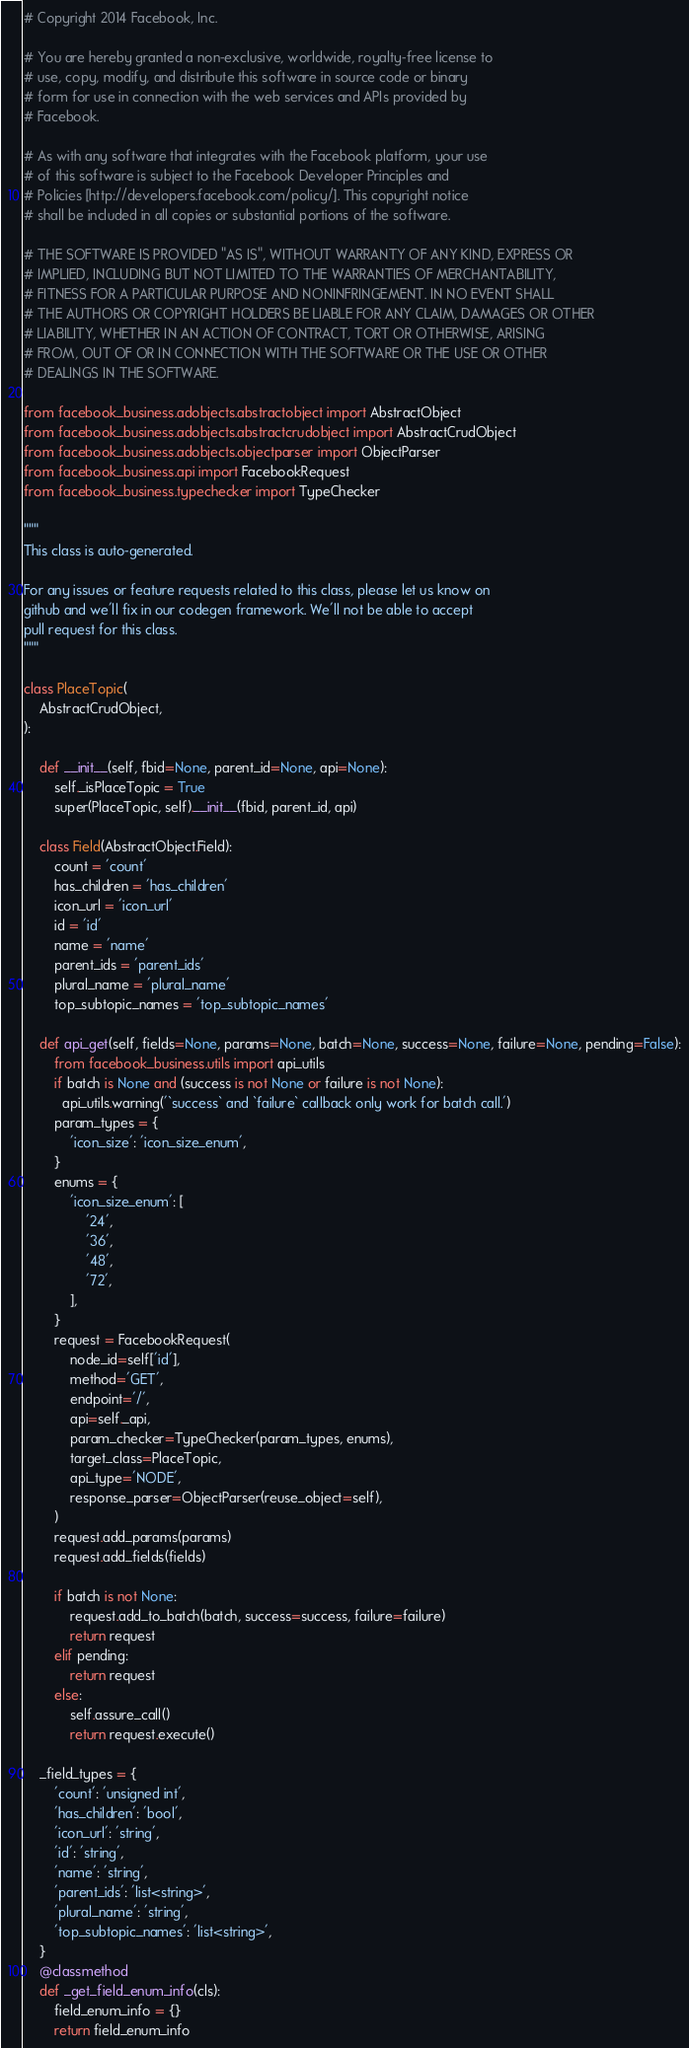<code> <loc_0><loc_0><loc_500><loc_500><_Python_># Copyright 2014 Facebook, Inc.

# You are hereby granted a non-exclusive, worldwide, royalty-free license to
# use, copy, modify, and distribute this software in source code or binary
# form for use in connection with the web services and APIs provided by
# Facebook.

# As with any software that integrates with the Facebook platform, your use
# of this software is subject to the Facebook Developer Principles and
# Policies [http://developers.facebook.com/policy/]. This copyright notice
# shall be included in all copies or substantial portions of the software.

# THE SOFTWARE IS PROVIDED "AS IS", WITHOUT WARRANTY OF ANY KIND, EXPRESS OR
# IMPLIED, INCLUDING BUT NOT LIMITED TO THE WARRANTIES OF MERCHANTABILITY,
# FITNESS FOR A PARTICULAR PURPOSE AND NONINFRINGEMENT. IN NO EVENT SHALL
# THE AUTHORS OR COPYRIGHT HOLDERS BE LIABLE FOR ANY CLAIM, DAMAGES OR OTHER
# LIABILITY, WHETHER IN AN ACTION OF CONTRACT, TORT OR OTHERWISE, ARISING
# FROM, OUT OF OR IN CONNECTION WITH THE SOFTWARE OR THE USE OR OTHER
# DEALINGS IN THE SOFTWARE.

from facebook_business.adobjects.abstractobject import AbstractObject
from facebook_business.adobjects.abstractcrudobject import AbstractCrudObject
from facebook_business.adobjects.objectparser import ObjectParser
from facebook_business.api import FacebookRequest
from facebook_business.typechecker import TypeChecker

"""
This class is auto-generated.

For any issues or feature requests related to this class, please let us know on
github and we'll fix in our codegen framework. We'll not be able to accept
pull request for this class.
"""

class PlaceTopic(
    AbstractCrudObject,
):

    def __init__(self, fbid=None, parent_id=None, api=None):
        self._isPlaceTopic = True
        super(PlaceTopic, self).__init__(fbid, parent_id, api)

    class Field(AbstractObject.Field):
        count = 'count'
        has_children = 'has_children'
        icon_url = 'icon_url'
        id = 'id'
        name = 'name'
        parent_ids = 'parent_ids'
        plural_name = 'plural_name'
        top_subtopic_names = 'top_subtopic_names'

    def api_get(self, fields=None, params=None, batch=None, success=None, failure=None, pending=False):
        from facebook_business.utils import api_utils
        if batch is None and (success is not None or failure is not None):
          api_utils.warning('`success` and `failure` callback only work for batch call.')
        param_types = {
            'icon_size': 'icon_size_enum',
        }
        enums = {
            'icon_size_enum': [
                '24',
                '36',
                '48',
                '72',
            ],
        }
        request = FacebookRequest(
            node_id=self['id'],
            method='GET',
            endpoint='/',
            api=self._api,
            param_checker=TypeChecker(param_types, enums),
            target_class=PlaceTopic,
            api_type='NODE',
            response_parser=ObjectParser(reuse_object=self),
        )
        request.add_params(params)
        request.add_fields(fields)

        if batch is not None:
            request.add_to_batch(batch, success=success, failure=failure)
            return request
        elif pending:
            return request
        else:
            self.assure_call()
            return request.execute()

    _field_types = {
        'count': 'unsigned int',
        'has_children': 'bool',
        'icon_url': 'string',
        'id': 'string',
        'name': 'string',
        'parent_ids': 'list<string>',
        'plural_name': 'string',
        'top_subtopic_names': 'list<string>',
    }
    @classmethod
    def _get_field_enum_info(cls):
        field_enum_info = {}
        return field_enum_info


</code> 